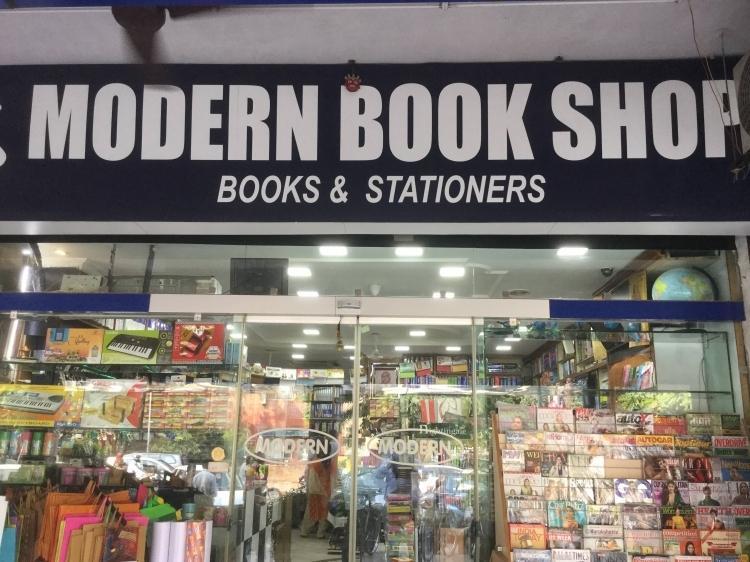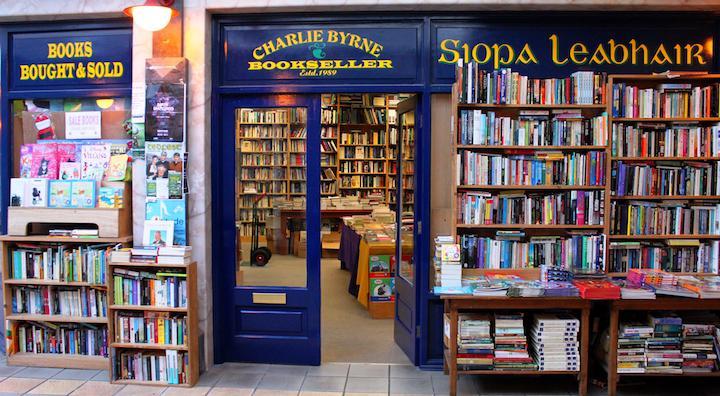The first image is the image on the left, the second image is the image on the right. For the images shown, is this caption "there is an open door in one of the images" true? Answer yes or no. Yes. 